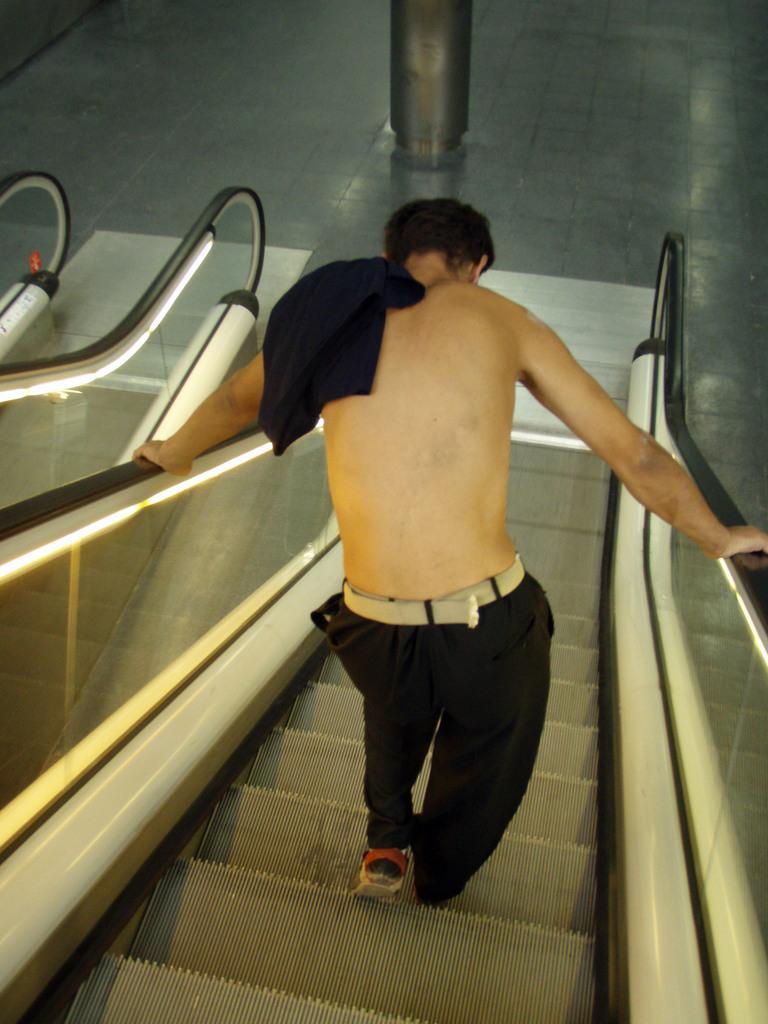Could you give a brief overview of what you see in this image? In the center of this picture we can see a person seems to be climbing down the escalators. In the background we can see the ground and an object seems to be the pillar and we can see some other objects. 